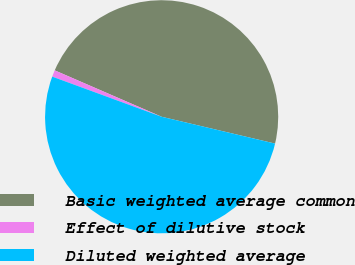Convert chart. <chart><loc_0><loc_0><loc_500><loc_500><pie_chart><fcel>Basic weighted average common<fcel>Effect of dilutive stock<fcel>Diluted weighted average<nl><fcel>47.18%<fcel>0.92%<fcel>51.9%<nl></chart> 